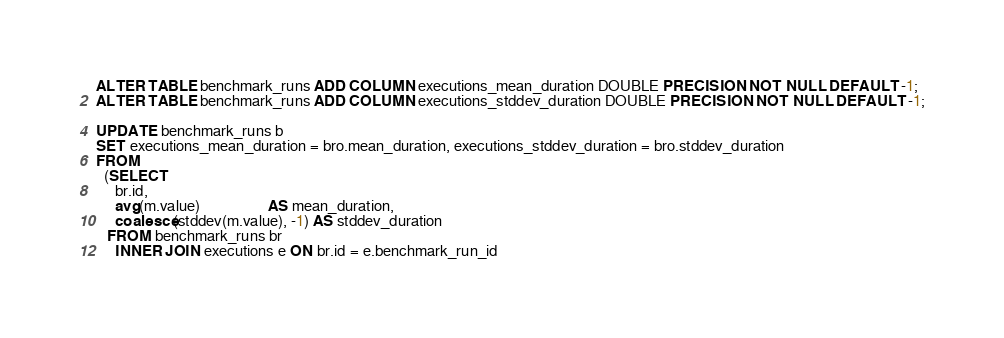Convert code to text. <code><loc_0><loc_0><loc_500><loc_500><_SQL_>ALTER TABLE benchmark_runs ADD COLUMN executions_mean_duration DOUBLE PRECISION NOT NULL DEFAULT -1;
ALTER TABLE benchmark_runs ADD COLUMN executions_stddev_duration DOUBLE PRECISION NOT NULL DEFAULT -1;

UPDATE benchmark_runs b
SET executions_mean_duration = bro.mean_duration, executions_stddev_duration = bro.stddev_duration
FROM
  (SELECT
     br.id,
     avg(m.value)                  AS mean_duration,
     coalesce(stddev(m.value), -1) AS stddev_duration
   FROM benchmark_runs br
     INNER JOIN executions e ON br.id = e.benchmark_run_id</code> 